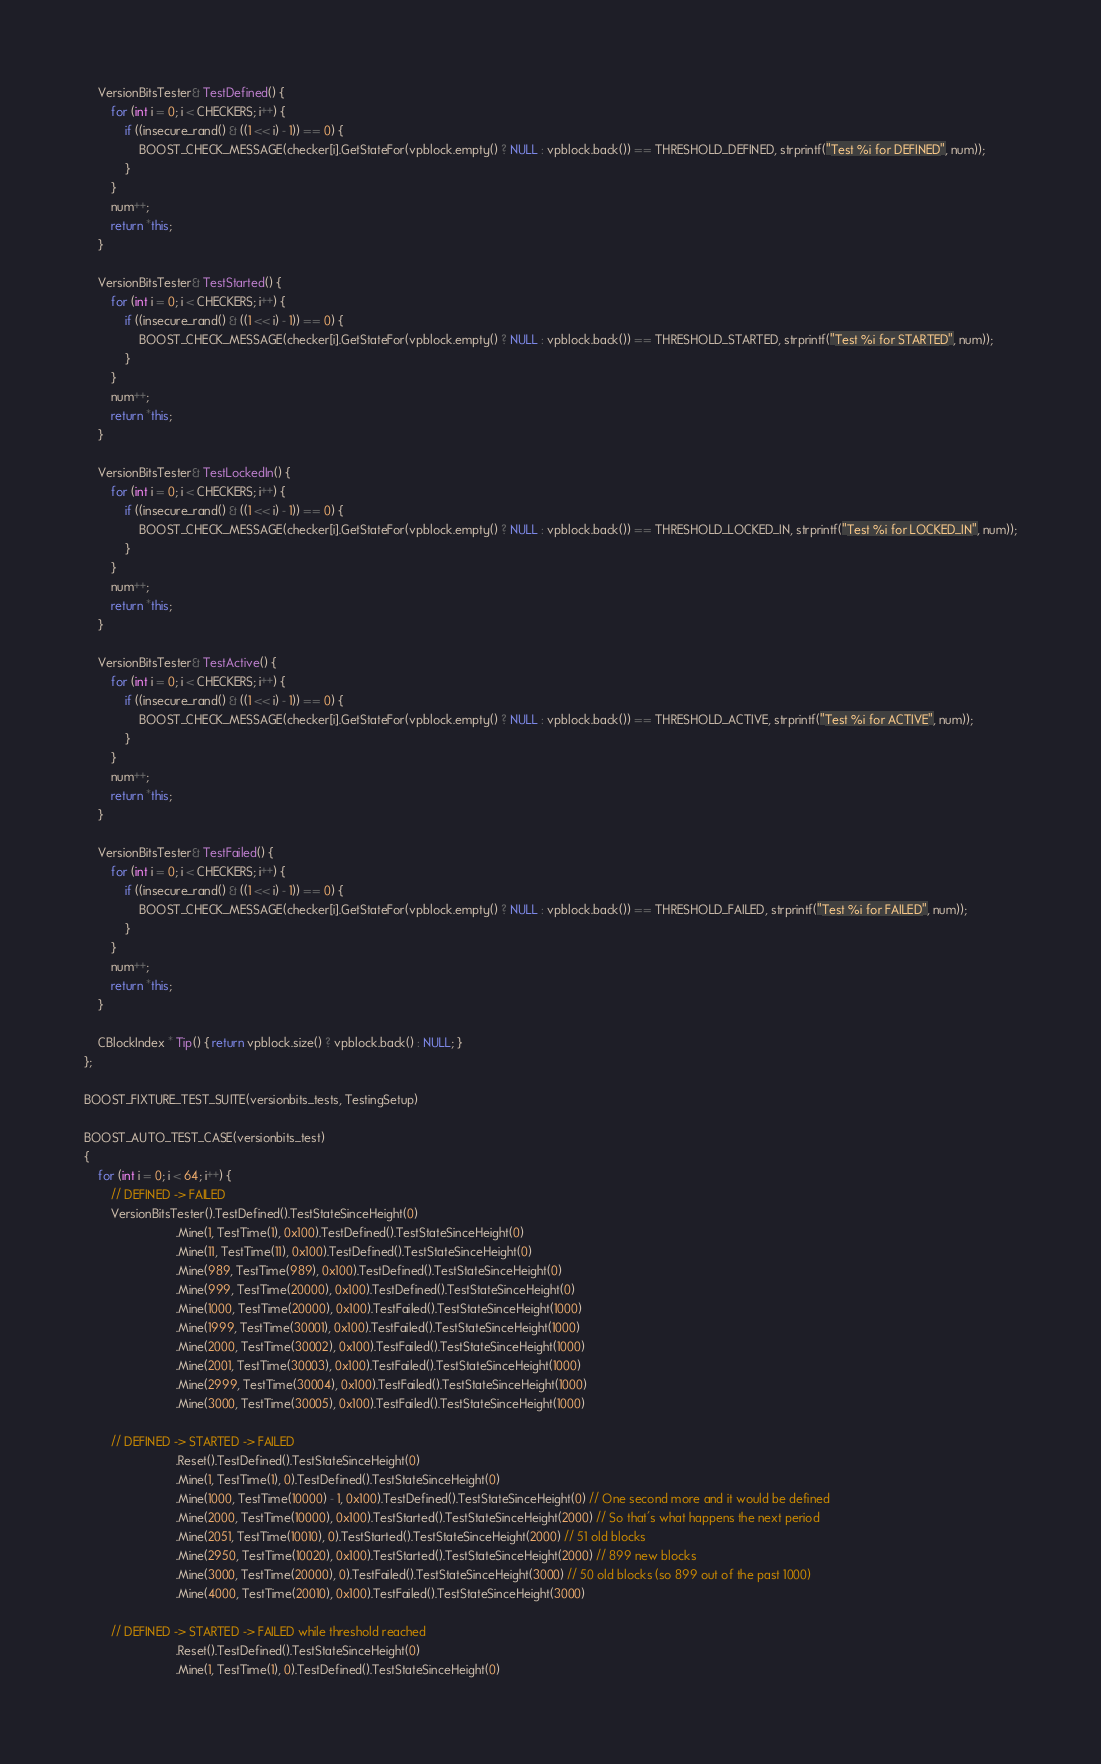Convert code to text. <code><loc_0><loc_0><loc_500><loc_500><_C++_>
    VersionBitsTester& TestDefined() {
        for (int i = 0; i < CHECKERS; i++) {
            if ((insecure_rand() & ((1 << i) - 1)) == 0) {
                BOOST_CHECK_MESSAGE(checker[i].GetStateFor(vpblock.empty() ? NULL : vpblock.back()) == THRESHOLD_DEFINED, strprintf("Test %i for DEFINED", num));
            }
        }
        num++;
        return *this;
    }

    VersionBitsTester& TestStarted() {
        for (int i = 0; i < CHECKERS; i++) {
            if ((insecure_rand() & ((1 << i) - 1)) == 0) {
                BOOST_CHECK_MESSAGE(checker[i].GetStateFor(vpblock.empty() ? NULL : vpblock.back()) == THRESHOLD_STARTED, strprintf("Test %i for STARTED", num));
            }
        }
        num++;
        return *this;
    }

    VersionBitsTester& TestLockedIn() {
        for (int i = 0; i < CHECKERS; i++) {
            if ((insecure_rand() & ((1 << i) - 1)) == 0) {
                BOOST_CHECK_MESSAGE(checker[i].GetStateFor(vpblock.empty() ? NULL : vpblock.back()) == THRESHOLD_LOCKED_IN, strprintf("Test %i for LOCKED_IN", num));
            }
        }
        num++;
        return *this;
    }

    VersionBitsTester& TestActive() {
        for (int i = 0; i < CHECKERS; i++) {
            if ((insecure_rand() & ((1 << i) - 1)) == 0) {
                BOOST_CHECK_MESSAGE(checker[i].GetStateFor(vpblock.empty() ? NULL : vpblock.back()) == THRESHOLD_ACTIVE, strprintf("Test %i for ACTIVE", num));
            }
        }
        num++;
        return *this;
    }

    VersionBitsTester& TestFailed() {
        for (int i = 0; i < CHECKERS; i++) {
            if ((insecure_rand() & ((1 << i) - 1)) == 0) {
                BOOST_CHECK_MESSAGE(checker[i].GetStateFor(vpblock.empty() ? NULL : vpblock.back()) == THRESHOLD_FAILED, strprintf("Test %i for FAILED", num));
            }
        }
        num++;
        return *this;
    }

    CBlockIndex * Tip() { return vpblock.size() ? vpblock.back() : NULL; }
};

BOOST_FIXTURE_TEST_SUITE(versionbits_tests, TestingSetup)

BOOST_AUTO_TEST_CASE(versionbits_test)
{
    for (int i = 0; i < 64; i++) {
        // DEFINED -> FAILED
        VersionBitsTester().TestDefined().TestStateSinceHeight(0)
                           .Mine(1, TestTime(1), 0x100).TestDefined().TestStateSinceHeight(0)
                           .Mine(11, TestTime(11), 0x100).TestDefined().TestStateSinceHeight(0)
                           .Mine(989, TestTime(989), 0x100).TestDefined().TestStateSinceHeight(0)
                           .Mine(999, TestTime(20000), 0x100).TestDefined().TestStateSinceHeight(0)
                           .Mine(1000, TestTime(20000), 0x100).TestFailed().TestStateSinceHeight(1000)
                           .Mine(1999, TestTime(30001), 0x100).TestFailed().TestStateSinceHeight(1000)
                           .Mine(2000, TestTime(30002), 0x100).TestFailed().TestStateSinceHeight(1000)
                           .Mine(2001, TestTime(30003), 0x100).TestFailed().TestStateSinceHeight(1000)
                           .Mine(2999, TestTime(30004), 0x100).TestFailed().TestStateSinceHeight(1000)
                           .Mine(3000, TestTime(30005), 0x100).TestFailed().TestStateSinceHeight(1000)

        // DEFINED -> STARTED -> FAILED
                           .Reset().TestDefined().TestStateSinceHeight(0)
                           .Mine(1, TestTime(1), 0).TestDefined().TestStateSinceHeight(0)
                           .Mine(1000, TestTime(10000) - 1, 0x100).TestDefined().TestStateSinceHeight(0) // One second more and it would be defined
                           .Mine(2000, TestTime(10000), 0x100).TestStarted().TestStateSinceHeight(2000) // So that's what happens the next period
                           .Mine(2051, TestTime(10010), 0).TestStarted().TestStateSinceHeight(2000) // 51 old blocks
                           .Mine(2950, TestTime(10020), 0x100).TestStarted().TestStateSinceHeight(2000) // 899 new blocks
                           .Mine(3000, TestTime(20000), 0).TestFailed().TestStateSinceHeight(3000) // 50 old blocks (so 899 out of the past 1000)
                           .Mine(4000, TestTime(20010), 0x100).TestFailed().TestStateSinceHeight(3000)

        // DEFINED -> STARTED -> FAILED while threshold reached
                           .Reset().TestDefined().TestStateSinceHeight(0)
                           .Mine(1, TestTime(1), 0).TestDefined().TestStateSinceHeight(0)</code> 